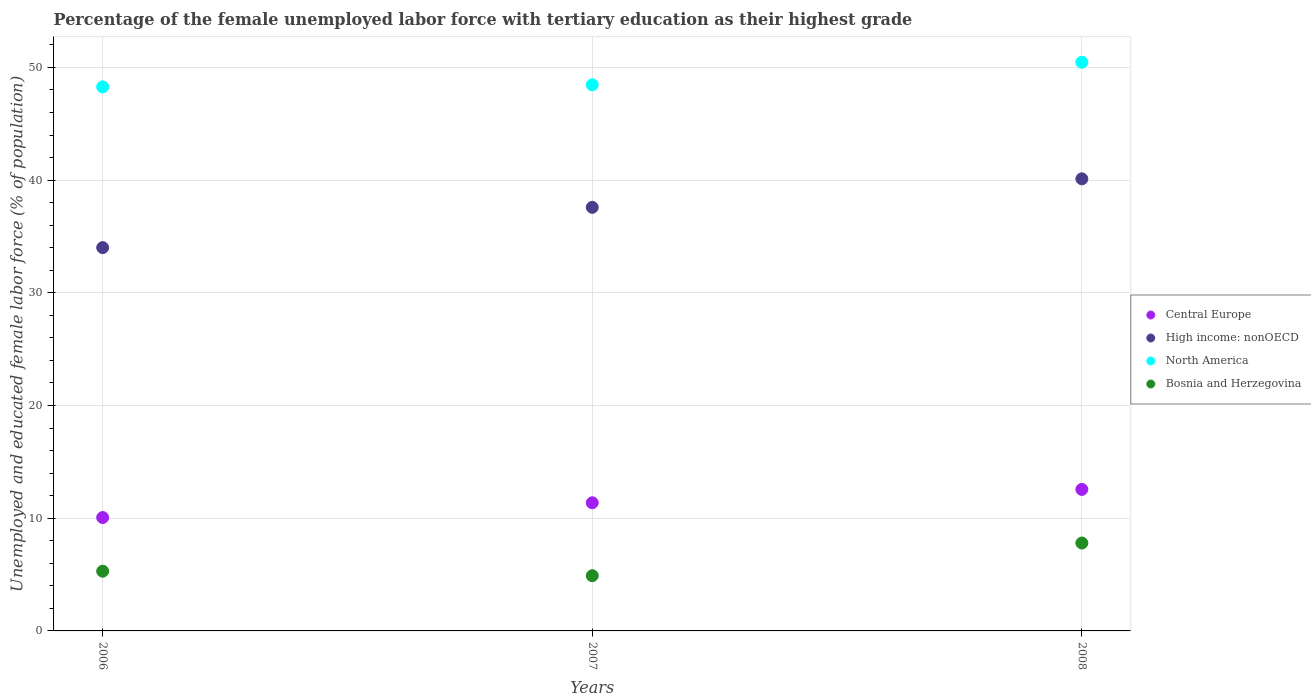What is the percentage of the unemployed female labor force with tertiary education in North America in 2006?
Your response must be concise. 48.27. Across all years, what is the maximum percentage of the unemployed female labor force with tertiary education in High income: nonOECD?
Offer a very short reply. 40.12. Across all years, what is the minimum percentage of the unemployed female labor force with tertiary education in High income: nonOECD?
Your response must be concise. 34.01. In which year was the percentage of the unemployed female labor force with tertiary education in North America minimum?
Offer a terse response. 2006. What is the total percentage of the unemployed female labor force with tertiary education in High income: nonOECD in the graph?
Keep it short and to the point. 111.72. What is the difference between the percentage of the unemployed female labor force with tertiary education in High income: nonOECD in 2007 and that in 2008?
Give a very brief answer. -2.53. What is the difference between the percentage of the unemployed female labor force with tertiary education in North America in 2007 and the percentage of the unemployed female labor force with tertiary education in Bosnia and Herzegovina in 2008?
Offer a terse response. 40.66. What is the average percentage of the unemployed female labor force with tertiary education in North America per year?
Keep it short and to the point. 49.06. In the year 2006, what is the difference between the percentage of the unemployed female labor force with tertiary education in Bosnia and Herzegovina and percentage of the unemployed female labor force with tertiary education in High income: nonOECD?
Your answer should be compact. -28.71. What is the ratio of the percentage of the unemployed female labor force with tertiary education in Bosnia and Herzegovina in 2007 to that in 2008?
Make the answer very short. 0.63. Is the percentage of the unemployed female labor force with tertiary education in Central Europe in 2006 less than that in 2007?
Provide a short and direct response. Yes. What is the difference between the highest and the second highest percentage of the unemployed female labor force with tertiary education in North America?
Your response must be concise. 2. What is the difference between the highest and the lowest percentage of the unemployed female labor force with tertiary education in North America?
Ensure brevity in your answer.  2.19. Is the sum of the percentage of the unemployed female labor force with tertiary education in North America in 2006 and 2008 greater than the maximum percentage of the unemployed female labor force with tertiary education in Bosnia and Herzegovina across all years?
Provide a short and direct response. Yes. Does the percentage of the unemployed female labor force with tertiary education in Central Europe monotonically increase over the years?
Offer a very short reply. Yes. Is the percentage of the unemployed female labor force with tertiary education in Central Europe strictly greater than the percentage of the unemployed female labor force with tertiary education in Bosnia and Herzegovina over the years?
Your answer should be compact. Yes. How many dotlines are there?
Offer a terse response. 4. How many years are there in the graph?
Keep it short and to the point. 3. Are the values on the major ticks of Y-axis written in scientific E-notation?
Your response must be concise. No. Does the graph contain any zero values?
Offer a very short reply. No. Does the graph contain grids?
Give a very brief answer. Yes. Where does the legend appear in the graph?
Your answer should be compact. Center right. How are the legend labels stacked?
Your answer should be compact. Vertical. What is the title of the graph?
Provide a succinct answer. Percentage of the female unemployed labor force with tertiary education as their highest grade. Does "Germany" appear as one of the legend labels in the graph?
Give a very brief answer. No. What is the label or title of the X-axis?
Offer a terse response. Years. What is the label or title of the Y-axis?
Offer a very short reply. Unemployed and educated female labor force (% of population). What is the Unemployed and educated female labor force (% of population) in Central Europe in 2006?
Keep it short and to the point. 10.06. What is the Unemployed and educated female labor force (% of population) of High income: nonOECD in 2006?
Provide a succinct answer. 34.01. What is the Unemployed and educated female labor force (% of population) of North America in 2006?
Your response must be concise. 48.27. What is the Unemployed and educated female labor force (% of population) in Bosnia and Herzegovina in 2006?
Your answer should be very brief. 5.3. What is the Unemployed and educated female labor force (% of population) in Central Europe in 2007?
Provide a short and direct response. 11.37. What is the Unemployed and educated female labor force (% of population) in High income: nonOECD in 2007?
Your response must be concise. 37.59. What is the Unemployed and educated female labor force (% of population) in North America in 2007?
Provide a short and direct response. 48.46. What is the Unemployed and educated female labor force (% of population) in Bosnia and Herzegovina in 2007?
Make the answer very short. 4.9. What is the Unemployed and educated female labor force (% of population) of Central Europe in 2008?
Provide a succinct answer. 12.56. What is the Unemployed and educated female labor force (% of population) of High income: nonOECD in 2008?
Your answer should be very brief. 40.12. What is the Unemployed and educated female labor force (% of population) in North America in 2008?
Provide a short and direct response. 50.46. What is the Unemployed and educated female labor force (% of population) in Bosnia and Herzegovina in 2008?
Give a very brief answer. 7.8. Across all years, what is the maximum Unemployed and educated female labor force (% of population) of Central Europe?
Offer a very short reply. 12.56. Across all years, what is the maximum Unemployed and educated female labor force (% of population) of High income: nonOECD?
Keep it short and to the point. 40.12. Across all years, what is the maximum Unemployed and educated female labor force (% of population) of North America?
Ensure brevity in your answer.  50.46. Across all years, what is the maximum Unemployed and educated female labor force (% of population) of Bosnia and Herzegovina?
Provide a succinct answer. 7.8. Across all years, what is the minimum Unemployed and educated female labor force (% of population) of Central Europe?
Make the answer very short. 10.06. Across all years, what is the minimum Unemployed and educated female labor force (% of population) in High income: nonOECD?
Your answer should be very brief. 34.01. Across all years, what is the minimum Unemployed and educated female labor force (% of population) of North America?
Ensure brevity in your answer.  48.27. Across all years, what is the minimum Unemployed and educated female labor force (% of population) in Bosnia and Herzegovina?
Your response must be concise. 4.9. What is the total Unemployed and educated female labor force (% of population) in Central Europe in the graph?
Offer a terse response. 33.99. What is the total Unemployed and educated female labor force (% of population) of High income: nonOECD in the graph?
Your answer should be very brief. 111.72. What is the total Unemployed and educated female labor force (% of population) of North America in the graph?
Your response must be concise. 147.19. What is the difference between the Unemployed and educated female labor force (% of population) in Central Europe in 2006 and that in 2007?
Your answer should be very brief. -1.31. What is the difference between the Unemployed and educated female labor force (% of population) of High income: nonOECD in 2006 and that in 2007?
Your response must be concise. -3.57. What is the difference between the Unemployed and educated female labor force (% of population) in North America in 2006 and that in 2007?
Provide a succinct answer. -0.19. What is the difference between the Unemployed and educated female labor force (% of population) in Central Europe in 2006 and that in 2008?
Ensure brevity in your answer.  -2.5. What is the difference between the Unemployed and educated female labor force (% of population) of High income: nonOECD in 2006 and that in 2008?
Provide a short and direct response. -6.1. What is the difference between the Unemployed and educated female labor force (% of population) in North America in 2006 and that in 2008?
Offer a very short reply. -2.19. What is the difference between the Unemployed and educated female labor force (% of population) in Bosnia and Herzegovina in 2006 and that in 2008?
Ensure brevity in your answer.  -2.5. What is the difference between the Unemployed and educated female labor force (% of population) of Central Europe in 2007 and that in 2008?
Provide a short and direct response. -1.19. What is the difference between the Unemployed and educated female labor force (% of population) of High income: nonOECD in 2007 and that in 2008?
Offer a very short reply. -2.53. What is the difference between the Unemployed and educated female labor force (% of population) in North America in 2007 and that in 2008?
Offer a very short reply. -2. What is the difference between the Unemployed and educated female labor force (% of population) of Bosnia and Herzegovina in 2007 and that in 2008?
Your response must be concise. -2.9. What is the difference between the Unemployed and educated female labor force (% of population) of Central Europe in 2006 and the Unemployed and educated female labor force (% of population) of High income: nonOECD in 2007?
Give a very brief answer. -27.52. What is the difference between the Unemployed and educated female labor force (% of population) in Central Europe in 2006 and the Unemployed and educated female labor force (% of population) in North America in 2007?
Your answer should be very brief. -38.4. What is the difference between the Unemployed and educated female labor force (% of population) of Central Europe in 2006 and the Unemployed and educated female labor force (% of population) of Bosnia and Herzegovina in 2007?
Provide a succinct answer. 5.16. What is the difference between the Unemployed and educated female labor force (% of population) of High income: nonOECD in 2006 and the Unemployed and educated female labor force (% of population) of North America in 2007?
Provide a succinct answer. -14.45. What is the difference between the Unemployed and educated female labor force (% of population) in High income: nonOECD in 2006 and the Unemployed and educated female labor force (% of population) in Bosnia and Herzegovina in 2007?
Give a very brief answer. 29.11. What is the difference between the Unemployed and educated female labor force (% of population) in North America in 2006 and the Unemployed and educated female labor force (% of population) in Bosnia and Herzegovina in 2007?
Provide a short and direct response. 43.37. What is the difference between the Unemployed and educated female labor force (% of population) of Central Europe in 2006 and the Unemployed and educated female labor force (% of population) of High income: nonOECD in 2008?
Provide a succinct answer. -30.05. What is the difference between the Unemployed and educated female labor force (% of population) in Central Europe in 2006 and the Unemployed and educated female labor force (% of population) in North America in 2008?
Provide a short and direct response. -40.4. What is the difference between the Unemployed and educated female labor force (% of population) in Central Europe in 2006 and the Unemployed and educated female labor force (% of population) in Bosnia and Herzegovina in 2008?
Keep it short and to the point. 2.26. What is the difference between the Unemployed and educated female labor force (% of population) of High income: nonOECD in 2006 and the Unemployed and educated female labor force (% of population) of North America in 2008?
Your answer should be compact. -16.45. What is the difference between the Unemployed and educated female labor force (% of population) in High income: nonOECD in 2006 and the Unemployed and educated female labor force (% of population) in Bosnia and Herzegovina in 2008?
Offer a very short reply. 26.21. What is the difference between the Unemployed and educated female labor force (% of population) in North America in 2006 and the Unemployed and educated female labor force (% of population) in Bosnia and Herzegovina in 2008?
Give a very brief answer. 40.47. What is the difference between the Unemployed and educated female labor force (% of population) in Central Europe in 2007 and the Unemployed and educated female labor force (% of population) in High income: nonOECD in 2008?
Provide a short and direct response. -28.74. What is the difference between the Unemployed and educated female labor force (% of population) in Central Europe in 2007 and the Unemployed and educated female labor force (% of population) in North America in 2008?
Make the answer very short. -39.09. What is the difference between the Unemployed and educated female labor force (% of population) of Central Europe in 2007 and the Unemployed and educated female labor force (% of population) of Bosnia and Herzegovina in 2008?
Keep it short and to the point. 3.57. What is the difference between the Unemployed and educated female labor force (% of population) in High income: nonOECD in 2007 and the Unemployed and educated female labor force (% of population) in North America in 2008?
Your answer should be very brief. -12.87. What is the difference between the Unemployed and educated female labor force (% of population) in High income: nonOECD in 2007 and the Unemployed and educated female labor force (% of population) in Bosnia and Herzegovina in 2008?
Your answer should be very brief. 29.79. What is the difference between the Unemployed and educated female labor force (% of population) in North America in 2007 and the Unemployed and educated female labor force (% of population) in Bosnia and Herzegovina in 2008?
Provide a short and direct response. 40.66. What is the average Unemployed and educated female labor force (% of population) of Central Europe per year?
Your answer should be very brief. 11.33. What is the average Unemployed and educated female labor force (% of population) in High income: nonOECD per year?
Make the answer very short. 37.24. What is the average Unemployed and educated female labor force (% of population) in North America per year?
Your response must be concise. 49.06. In the year 2006, what is the difference between the Unemployed and educated female labor force (% of population) in Central Europe and Unemployed and educated female labor force (% of population) in High income: nonOECD?
Ensure brevity in your answer.  -23.95. In the year 2006, what is the difference between the Unemployed and educated female labor force (% of population) of Central Europe and Unemployed and educated female labor force (% of population) of North America?
Provide a succinct answer. -38.21. In the year 2006, what is the difference between the Unemployed and educated female labor force (% of population) in Central Europe and Unemployed and educated female labor force (% of population) in Bosnia and Herzegovina?
Give a very brief answer. 4.76. In the year 2006, what is the difference between the Unemployed and educated female labor force (% of population) of High income: nonOECD and Unemployed and educated female labor force (% of population) of North America?
Keep it short and to the point. -14.26. In the year 2006, what is the difference between the Unemployed and educated female labor force (% of population) of High income: nonOECD and Unemployed and educated female labor force (% of population) of Bosnia and Herzegovina?
Ensure brevity in your answer.  28.71. In the year 2006, what is the difference between the Unemployed and educated female labor force (% of population) in North America and Unemployed and educated female labor force (% of population) in Bosnia and Herzegovina?
Offer a terse response. 42.97. In the year 2007, what is the difference between the Unemployed and educated female labor force (% of population) of Central Europe and Unemployed and educated female labor force (% of population) of High income: nonOECD?
Offer a terse response. -26.21. In the year 2007, what is the difference between the Unemployed and educated female labor force (% of population) in Central Europe and Unemployed and educated female labor force (% of population) in North America?
Give a very brief answer. -37.09. In the year 2007, what is the difference between the Unemployed and educated female labor force (% of population) of Central Europe and Unemployed and educated female labor force (% of population) of Bosnia and Herzegovina?
Ensure brevity in your answer.  6.47. In the year 2007, what is the difference between the Unemployed and educated female labor force (% of population) in High income: nonOECD and Unemployed and educated female labor force (% of population) in North America?
Your response must be concise. -10.87. In the year 2007, what is the difference between the Unemployed and educated female labor force (% of population) in High income: nonOECD and Unemployed and educated female labor force (% of population) in Bosnia and Herzegovina?
Offer a very short reply. 32.69. In the year 2007, what is the difference between the Unemployed and educated female labor force (% of population) of North America and Unemployed and educated female labor force (% of population) of Bosnia and Herzegovina?
Provide a short and direct response. 43.56. In the year 2008, what is the difference between the Unemployed and educated female labor force (% of population) of Central Europe and Unemployed and educated female labor force (% of population) of High income: nonOECD?
Make the answer very short. -27.56. In the year 2008, what is the difference between the Unemployed and educated female labor force (% of population) of Central Europe and Unemployed and educated female labor force (% of population) of North America?
Your answer should be compact. -37.9. In the year 2008, what is the difference between the Unemployed and educated female labor force (% of population) in Central Europe and Unemployed and educated female labor force (% of population) in Bosnia and Herzegovina?
Give a very brief answer. 4.76. In the year 2008, what is the difference between the Unemployed and educated female labor force (% of population) in High income: nonOECD and Unemployed and educated female labor force (% of population) in North America?
Provide a short and direct response. -10.34. In the year 2008, what is the difference between the Unemployed and educated female labor force (% of population) of High income: nonOECD and Unemployed and educated female labor force (% of population) of Bosnia and Herzegovina?
Offer a terse response. 32.32. In the year 2008, what is the difference between the Unemployed and educated female labor force (% of population) of North America and Unemployed and educated female labor force (% of population) of Bosnia and Herzegovina?
Your answer should be compact. 42.66. What is the ratio of the Unemployed and educated female labor force (% of population) of Central Europe in 2006 to that in 2007?
Keep it short and to the point. 0.88. What is the ratio of the Unemployed and educated female labor force (% of population) of High income: nonOECD in 2006 to that in 2007?
Your response must be concise. 0.9. What is the ratio of the Unemployed and educated female labor force (% of population) in North America in 2006 to that in 2007?
Offer a very short reply. 1. What is the ratio of the Unemployed and educated female labor force (% of population) of Bosnia and Herzegovina in 2006 to that in 2007?
Offer a terse response. 1.08. What is the ratio of the Unemployed and educated female labor force (% of population) of Central Europe in 2006 to that in 2008?
Keep it short and to the point. 0.8. What is the ratio of the Unemployed and educated female labor force (% of population) of High income: nonOECD in 2006 to that in 2008?
Offer a very short reply. 0.85. What is the ratio of the Unemployed and educated female labor force (% of population) in North America in 2006 to that in 2008?
Your response must be concise. 0.96. What is the ratio of the Unemployed and educated female labor force (% of population) of Bosnia and Herzegovina in 2006 to that in 2008?
Keep it short and to the point. 0.68. What is the ratio of the Unemployed and educated female labor force (% of population) in Central Europe in 2007 to that in 2008?
Offer a very short reply. 0.91. What is the ratio of the Unemployed and educated female labor force (% of population) in High income: nonOECD in 2007 to that in 2008?
Offer a very short reply. 0.94. What is the ratio of the Unemployed and educated female labor force (% of population) in North America in 2007 to that in 2008?
Keep it short and to the point. 0.96. What is the ratio of the Unemployed and educated female labor force (% of population) in Bosnia and Herzegovina in 2007 to that in 2008?
Keep it short and to the point. 0.63. What is the difference between the highest and the second highest Unemployed and educated female labor force (% of population) in Central Europe?
Your response must be concise. 1.19. What is the difference between the highest and the second highest Unemployed and educated female labor force (% of population) in High income: nonOECD?
Your answer should be very brief. 2.53. What is the difference between the highest and the second highest Unemployed and educated female labor force (% of population) of North America?
Keep it short and to the point. 2. What is the difference between the highest and the second highest Unemployed and educated female labor force (% of population) of Bosnia and Herzegovina?
Ensure brevity in your answer.  2.5. What is the difference between the highest and the lowest Unemployed and educated female labor force (% of population) of Central Europe?
Give a very brief answer. 2.5. What is the difference between the highest and the lowest Unemployed and educated female labor force (% of population) of High income: nonOECD?
Make the answer very short. 6.1. What is the difference between the highest and the lowest Unemployed and educated female labor force (% of population) in North America?
Offer a terse response. 2.19. What is the difference between the highest and the lowest Unemployed and educated female labor force (% of population) in Bosnia and Herzegovina?
Give a very brief answer. 2.9. 